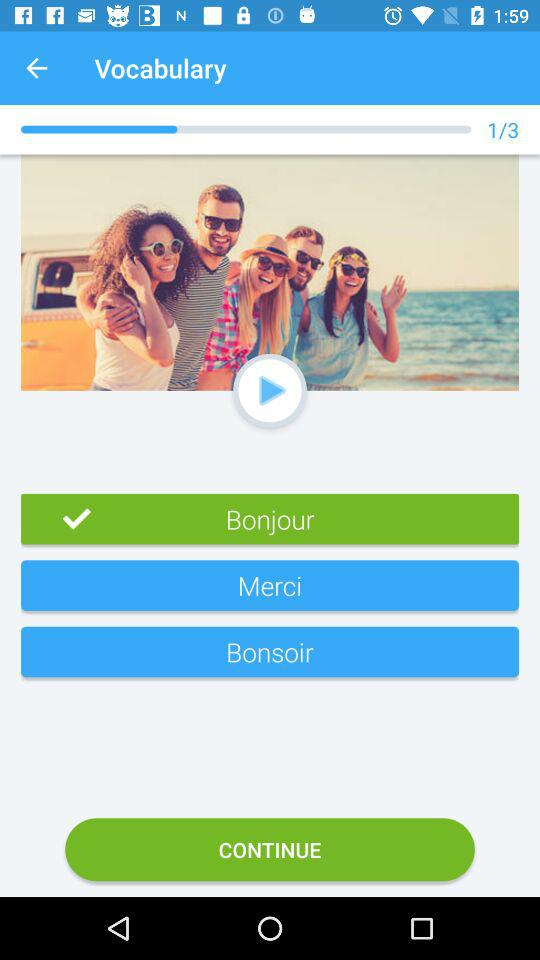How many sets are available? There is 1 set available. 